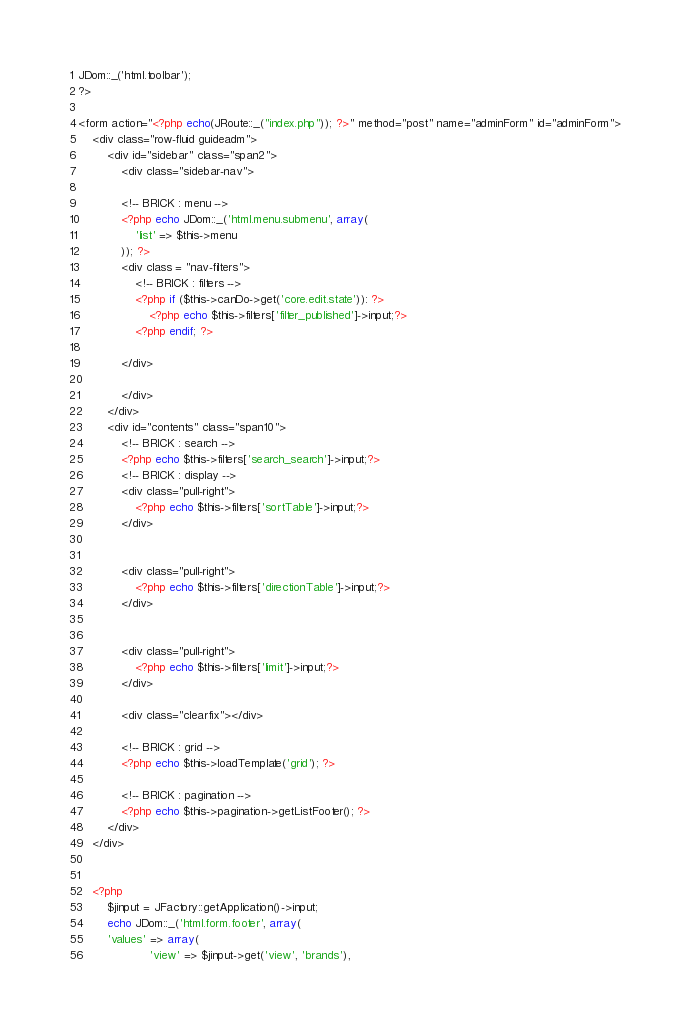Convert code to text. <code><loc_0><loc_0><loc_500><loc_500><_PHP_>JDom::_('html.toolbar');
?>

<form action="<?php echo(JRoute::_("index.php")); ?>" method="post" name="adminForm" id="adminForm">
	<div class="row-fluid guideadm">
		<div id="sidebar" class="span2">
			<div class="sidebar-nav">

			<!-- BRICK : menu -->
			<?php echo JDom::_('html.menu.submenu', array(
				'list' => $this->menu
			)); ?>
			<div class = "nav-filters">
				<!-- BRICK : filters -->
				<?php if ($this->canDo->get('core.edit.state')): ?>
					<?php echo $this->filters['filter_published']->input;?>
				<?php endif; ?>

			</div>

			</div>
		</div>
		<div id="contents" class="span10">
			<!-- BRICK : search -->
			<?php echo $this->filters['search_search']->input;?>
			<!-- BRICK : display -->
			<div class="pull-right">
				<?php echo $this->filters['sortTable']->input;?>
			</div>


			<div class="pull-right">
				<?php echo $this->filters['directionTable']->input;?>
			</div>


			<div class="pull-right">
				<?php echo $this->filters['limit']->input;?>
			</div>

			<div class="clearfix"></div>

			<!-- BRICK : grid -->
			<?php echo $this->loadTemplate('grid'); ?>

			<!-- BRICK : pagination -->
			<?php echo $this->pagination->getListFooter(); ?>
		</div>
	</div>


	<?php 
		$jinput = JFactory::getApplication()->input;
		echo JDom::_('html.form.footer', array(
		'values' => array(
					'view' => $jinput->get('view', 'brands'),</code> 